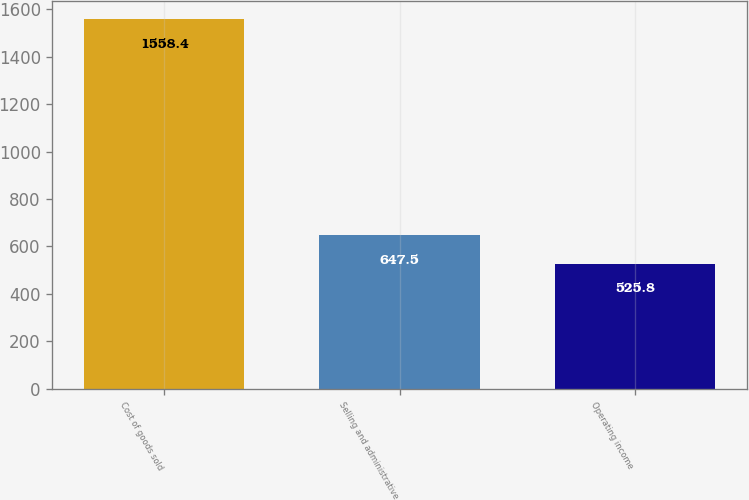Convert chart to OTSL. <chart><loc_0><loc_0><loc_500><loc_500><bar_chart><fcel>Cost of goods sold<fcel>Selling and administrative<fcel>Operating income<nl><fcel>1558.4<fcel>647.5<fcel>525.8<nl></chart> 